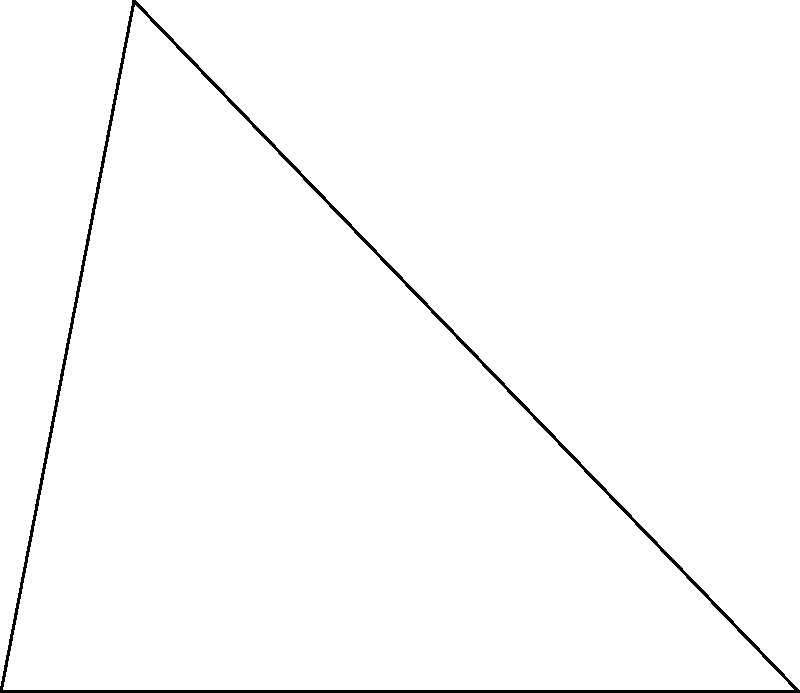In a healing garden, two special stones are placed at different positions from a central point O. Stone A is 5 meters directly east of O, while stone B is placed at an angle of 60° north of east from O. What is the distance between stones A and B? Let's approach this step-by-step using trigonometry:

1) We can treat this as a triangle problem, where:
   - O is the vertex
   - OA is one side (known to be 5 meters)
   - OB is another side (length unknown but at a 60° angle from OA)
   - AB is the side we need to find

2) This forms a triangle OAB, where we know:
   - The length of one side (OA = 5 m)
   - One angle (∠AOB = 60°)

3) To find AB, we can use the law of cosines:

   $$c^2 = a^2 + b^2 - 2ab \cos(C)$$

   Where:
   - c is the length we're trying to find (AB)
   - a and b are the other two sides (OA and OB)
   - C is the angle between sides a and b (60°)

4) We know OA = 5 m, but we don't know OB. However, due to the symmetry of the triangle, OB must also equal 5 m.

5) Plugging into the formula:

   $$AB^2 = 5^2 + 5^2 - 2(5)(5)\cos(60°)$$

6) Simplify:
   $$AB^2 = 25 + 25 - 50\cos(60°)$$
   $$AB^2 = 50 - 50(\frac{1}{2})$$ (as $\cos(60°) = \frac{1}{2}$)
   $$AB^2 = 50 - 25 = 25$$

7) Take the square root of both sides:
   $$AB = \sqrt{25} = 5$$

Therefore, the distance between stones A and B is 5 meters.
Answer: 5 meters 